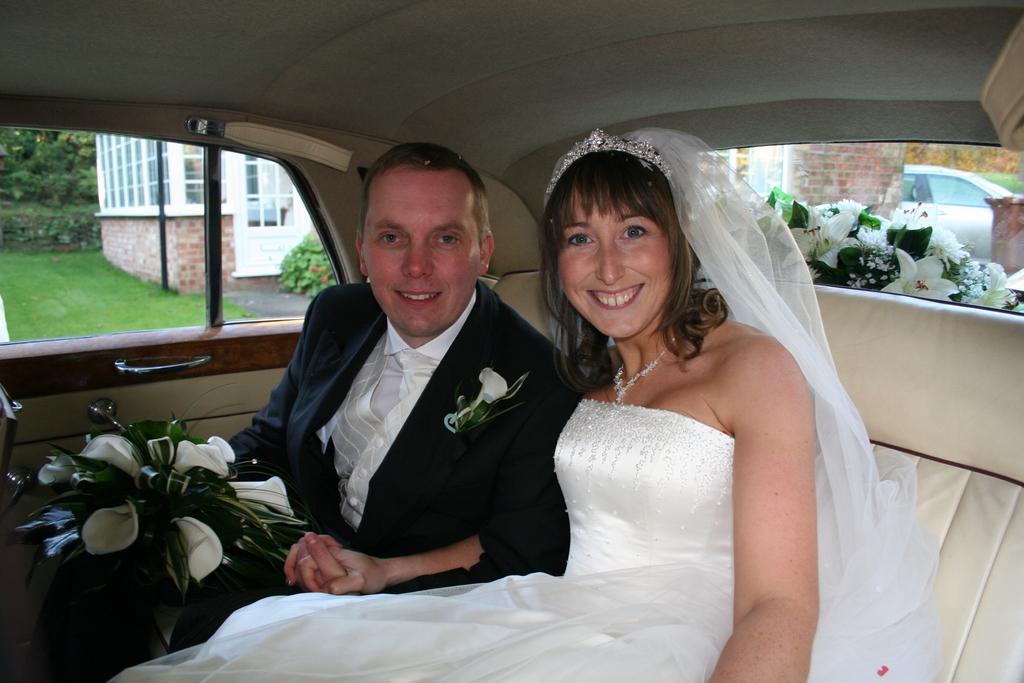Could you give a brief overview of what you see in this image? In a picture one woman and man are seated in a car where the person is holding a bouquet, behind them there is another car and behind him outside of the car there is a one building surrounded by trees and grass. The woman is wearing a white gown with tiara on her head along with a veil. 